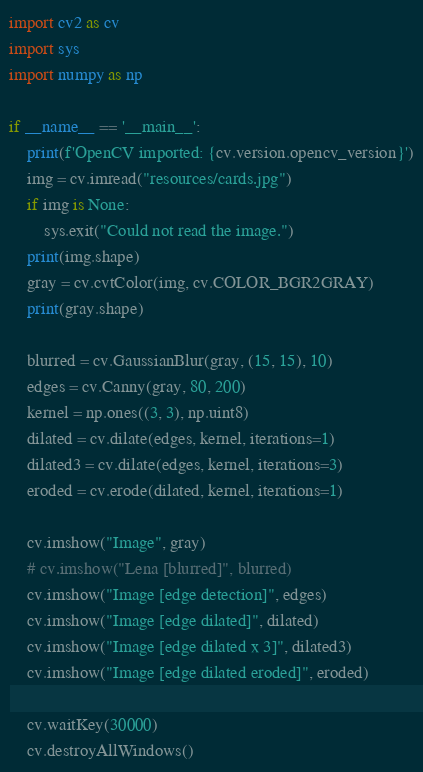<code> <loc_0><loc_0><loc_500><loc_500><_Python_>import cv2 as cv
import sys
import numpy as np

if __name__ == '__main__':
    print(f'OpenCV imported: {cv.version.opencv_version}')
    img = cv.imread("resources/cards.jpg")
    if img is None:
        sys.exit("Could not read the image.")
    print(img.shape)
    gray = cv.cvtColor(img, cv.COLOR_BGR2GRAY)
    print(gray.shape)

    blurred = cv.GaussianBlur(gray, (15, 15), 10)
    edges = cv.Canny(gray, 80, 200)
    kernel = np.ones((3, 3), np.uint8)
    dilated = cv.dilate(edges, kernel, iterations=1)
    dilated3 = cv.dilate(edges, kernel, iterations=3)
    eroded = cv.erode(dilated, kernel, iterations=1)

    cv.imshow("Image", gray)
    # cv.imshow("Lena [blurred]", blurred)
    cv.imshow("Image [edge detection]", edges)
    cv.imshow("Image [edge dilated]", dilated)
    cv.imshow("Image [edge dilated x 3]", dilated3)
    cv.imshow("Image [edge dilated eroded]", eroded)

    cv.waitKey(30000)
    cv.destroyAllWindows()
</code> 